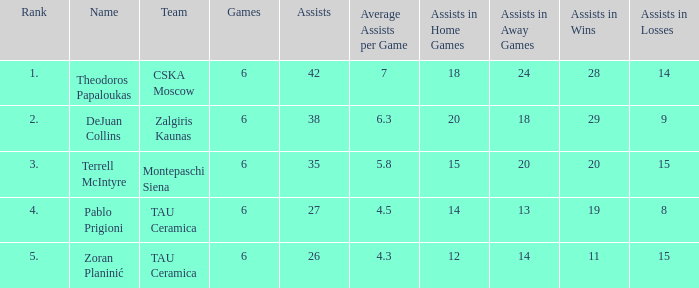What is the least number of assists among players ranked 2? 38.0. 